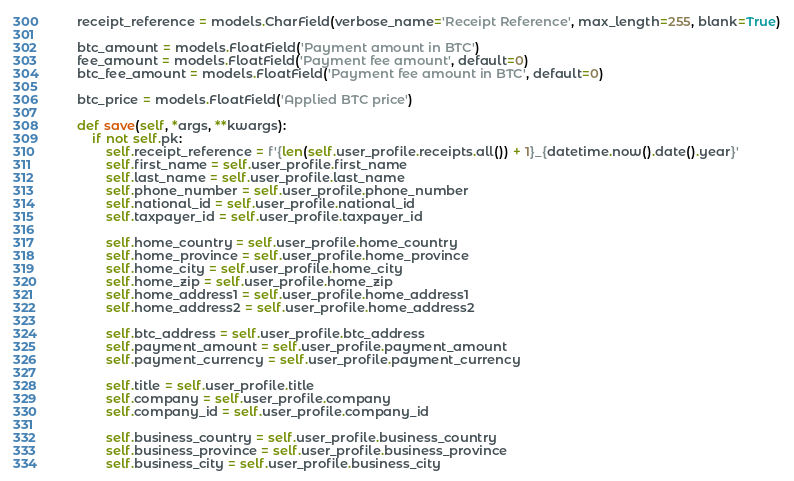<code> <loc_0><loc_0><loc_500><loc_500><_Python_>    receipt_reference = models.CharField(verbose_name='Receipt Reference', max_length=255, blank=True)

    btc_amount = models.FloatField('Payment amount in BTC')
    fee_amount = models.FloatField('Payment fee amount', default=0)
    btc_fee_amount = models.FloatField('Payment fee amount in BTC', default=0)

    btc_price = models.FloatField('Applied BTC price')

    def save(self, *args, **kwargs):
        if not self.pk:
            self.receipt_reference = f'{len(self.user_profile.receipts.all()) + 1}_{datetime.now().date().year}'
            self.first_name = self.user_profile.first_name
            self.last_name = self.user_profile.last_name
            self.phone_number = self.user_profile.phone_number
            self.national_id = self.user_profile.national_id
            self.taxpayer_id = self.user_profile.taxpayer_id

            self.home_country = self.user_profile.home_country
            self.home_province = self.user_profile.home_province
            self.home_city = self.user_profile.home_city
            self.home_zip = self.user_profile.home_zip
            self.home_address1 = self.user_profile.home_address1
            self.home_address2 = self.user_profile.home_address2

            self.btc_address = self.user_profile.btc_address
            self.payment_amount = self.user_profile.payment_amount
            self.payment_currency = self.user_profile.payment_currency

            self.title = self.user_profile.title
            self.company = self.user_profile.company
            self.company_id = self.user_profile.company_id

            self.business_country = self.user_profile.business_country
            self.business_province = self.user_profile.business_province
            self.business_city = self.user_profile.business_city</code> 